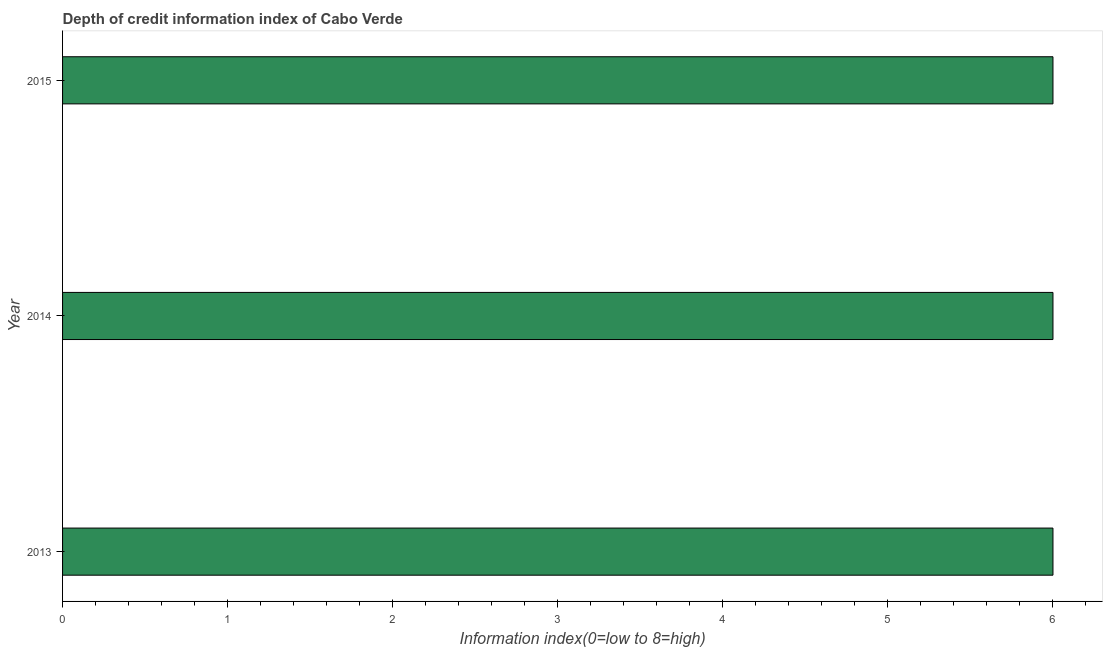Does the graph contain any zero values?
Your response must be concise. No. What is the title of the graph?
Provide a short and direct response. Depth of credit information index of Cabo Verde. What is the label or title of the X-axis?
Keep it short and to the point. Information index(0=low to 8=high). What is the label or title of the Y-axis?
Your response must be concise. Year. Across all years, what is the maximum depth of credit information index?
Offer a very short reply. 6. What is the average depth of credit information index per year?
Offer a very short reply. 6. In how many years, is the depth of credit information index greater than 2.4 ?
Keep it short and to the point. 3. Do a majority of the years between 2014 and 2013 (inclusive) have depth of credit information index greater than 6 ?
Your answer should be very brief. No. What is the ratio of the depth of credit information index in 2014 to that in 2015?
Ensure brevity in your answer.  1. Is the sum of the depth of credit information index in 2013 and 2015 greater than the maximum depth of credit information index across all years?
Keep it short and to the point. Yes. In how many years, is the depth of credit information index greater than the average depth of credit information index taken over all years?
Ensure brevity in your answer.  0. How many bars are there?
Your response must be concise. 3. How many years are there in the graph?
Give a very brief answer. 3. What is the difference between two consecutive major ticks on the X-axis?
Make the answer very short. 1. Are the values on the major ticks of X-axis written in scientific E-notation?
Your response must be concise. No. What is the Information index(0=low to 8=high) in 2013?
Offer a very short reply. 6. What is the Information index(0=low to 8=high) in 2014?
Provide a succinct answer. 6. What is the Information index(0=low to 8=high) in 2015?
Give a very brief answer. 6. What is the difference between the Information index(0=low to 8=high) in 2013 and 2015?
Your response must be concise. 0. What is the difference between the Information index(0=low to 8=high) in 2014 and 2015?
Your response must be concise. 0. What is the ratio of the Information index(0=low to 8=high) in 2013 to that in 2015?
Provide a short and direct response. 1. What is the ratio of the Information index(0=low to 8=high) in 2014 to that in 2015?
Your answer should be very brief. 1. 